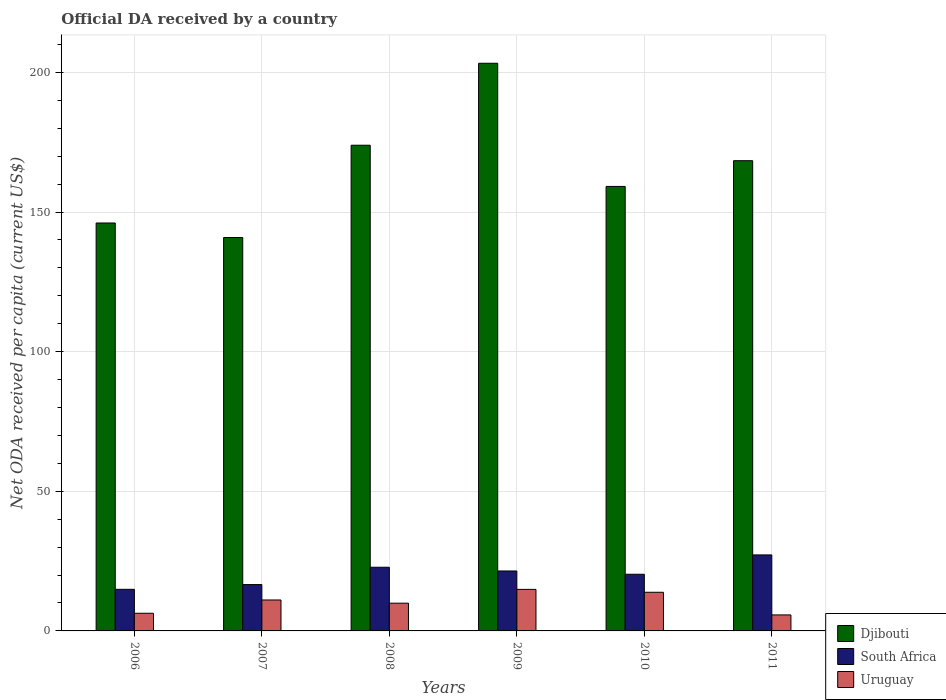How many different coloured bars are there?
Make the answer very short. 3. Are the number of bars per tick equal to the number of legend labels?
Ensure brevity in your answer.  Yes. How many bars are there on the 1st tick from the left?
Make the answer very short. 3. What is the label of the 5th group of bars from the left?
Your answer should be compact. 2010. What is the ODA received in in Djibouti in 2010?
Ensure brevity in your answer.  159.17. Across all years, what is the maximum ODA received in in Uruguay?
Give a very brief answer. 14.88. Across all years, what is the minimum ODA received in in Uruguay?
Make the answer very short. 5.73. In which year was the ODA received in in Djibouti maximum?
Offer a terse response. 2009. In which year was the ODA received in in South Africa minimum?
Provide a succinct answer. 2006. What is the total ODA received in in Djibouti in the graph?
Provide a succinct answer. 991.74. What is the difference between the ODA received in in Uruguay in 2008 and that in 2009?
Make the answer very short. -4.94. What is the difference between the ODA received in in Djibouti in 2007 and the ODA received in in Uruguay in 2009?
Provide a short and direct response. 126.01. What is the average ODA received in in South Africa per year?
Provide a succinct answer. 20.55. In the year 2007, what is the difference between the ODA received in in Djibouti and ODA received in in South Africa?
Ensure brevity in your answer.  124.29. In how many years, is the ODA received in in South Africa greater than 180 US$?
Make the answer very short. 0. What is the ratio of the ODA received in in South Africa in 2006 to that in 2011?
Provide a short and direct response. 0.55. Is the ODA received in in Djibouti in 2006 less than that in 2009?
Keep it short and to the point. Yes. Is the difference between the ODA received in in Djibouti in 2009 and 2010 greater than the difference between the ODA received in in South Africa in 2009 and 2010?
Give a very brief answer. Yes. What is the difference between the highest and the second highest ODA received in in South Africa?
Your answer should be compact. 4.41. What is the difference between the highest and the lowest ODA received in in Uruguay?
Your answer should be very brief. 9.15. Is the sum of the ODA received in in South Africa in 2008 and 2011 greater than the maximum ODA received in in Uruguay across all years?
Ensure brevity in your answer.  Yes. What does the 3rd bar from the left in 2006 represents?
Make the answer very short. Uruguay. What does the 3rd bar from the right in 2011 represents?
Offer a terse response. Djibouti. How many bars are there?
Your answer should be very brief. 18. Are all the bars in the graph horizontal?
Your response must be concise. No. What is the difference between two consecutive major ticks on the Y-axis?
Offer a terse response. 50. Are the values on the major ticks of Y-axis written in scientific E-notation?
Provide a short and direct response. No. Does the graph contain any zero values?
Make the answer very short. No. Where does the legend appear in the graph?
Offer a terse response. Bottom right. How many legend labels are there?
Your answer should be compact. 3. What is the title of the graph?
Give a very brief answer. Official DA received by a country. Does "Eritrea" appear as one of the legend labels in the graph?
Offer a very short reply. No. What is the label or title of the Y-axis?
Provide a short and direct response. Net ODA received per capita (current US$). What is the Net ODA received per capita (current US$) of Djibouti in 2006?
Offer a terse response. 146.08. What is the Net ODA received per capita (current US$) in South Africa in 2006?
Ensure brevity in your answer.  14.9. What is the Net ODA received per capita (current US$) of Uruguay in 2006?
Make the answer very short. 6.33. What is the Net ODA received per capita (current US$) in Djibouti in 2007?
Ensure brevity in your answer.  140.88. What is the Net ODA received per capita (current US$) in South Africa in 2007?
Provide a short and direct response. 16.6. What is the Net ODA received per capita (current US$) in Uruguay in 2007?
Give a very brief answer. 11.08. What is the Net ODA received per capita (current US$) of Djibouti in 2008?
Provide a short and direct response. 173.93. What is the Net ODA received per capita (current US$) of South Africa in 2008?
Offer a terse response. 22.8. What is the Net ODA received per capita (current US$) of Uruguay in 2008?
Provide a succinct answer. 9.93. What is the Net ODA received per capita (current US$) of Djibouti in 2009?
Give a very brief answer. 203.28. What is the Net ODA received per capita (current US$) in South Africa in 2009?
Offer a terse response. 21.47. What is the Net ODA received per capita (current US$) of Uruguay in 2009?
Ensure brevity in your answer.  14.88. What is the Net ODA received per capita (current US$) of Djibouti in 2010?
Your answer should be compact. 159.17. What is the Net ODA received per capita (current US$) of South Africa in 2010?
Offer a terse response. 20.29. What is the Net ODA received per capita (current US$) of Uruguay in 2010?
Ensure brevity in your answer.  13.84. What is the Net ODA received per capita (current US$) in Djibouti in 2011?
Provide a succinct answer. 168.39. What is the Net ODA received per capita (current US$) in South Africa in 2011?
Give a very brief answer. 27.22. What is the Net ODA received per capita (current US$) in Uruguay in 2011?
Provide a succinct answer. 5.73. Across all years, what is the maximum Net ODA received per capita (current US$) of Djibouti?
Offer a very short reply. 203.28. Across all years, what is the maximum Net ODA received per capita (current US$) in South Africa?
Give a very brief answer. 27.22. Across all years, what is the maximum Net ODA received per capita (current US$) in Uruguay?
Your answer should be very brief. 14.88. Across all years, what is the minimum Net ODA received per capita (current US$) of Djibouti?
Your response must be concise. 140.88. Across all years, what is the minimum Net ODA received per capita (current US$) in South Africa?
Make the answer very short. 14.9. Across all years, what is the minimum Net ODA received per capita (current US$) in Uruguay?
Keep it short and to the point. 5.73. What is the total Net ODA received per capita (current US$) in Djibouti in the graph?
Provide a succinct answer. 991.74. What is the total Net ODA received per capita (current US$) of South Africa in the graph?
Provide a succinct answer. 123.27. What is the total Net ODA received per capita (current US$) in Uruguay in the graph?
Offer a terse response. 61.79. What is the difference between the Net ODA received per capita (current US$) of Djibouti in 2006 and that in 2007?
Ensure brevity in your answer.  5.2. What is the difference between the Net ODA received per capita (current US$) of South Africa in 2006 and that in 2007?
Offer a terse response. -1.7. What is the difference between the Net ODA received per capita (current US$) of Uruguay in 2006 and that in 2007?
Offer a very short reply. -4.76. What is the difference between the Net ODA received per capita (current US$) in Djibouti in 2006 and that in 2008?
Your answer should be compact. -27.85. What is the difference between the Net ODA received per capita (current US$) in South Africa in 2006 and that in 2008?
Your response must be concise. -7.9. What is the difference between the Net ODA received per capita (current US$) of Uruguay in 2006 and that in 2008?
Provide a short and direct response. -3.61. What is the difference between the Net ODA received per capita (current US$) of Djibouti in 2006 and that in 2009?
Keep it short and to the point. -57.2. What is the difference between the Net ODA received per capita (current US$) in South Africa in 2006 and that in 2009?
Your answer should be compact. -6.57. What is the difference between the Net ODA received per capita (current US$) in Uruguay in 2006 and that in 2009?
Make the answer very short. -8.55. What is the difference between the Net ODA received per capita (current US$) of Djibouti in 2006 and that in 2010?
Your response must be concise. -13.09. What is the difference between the Net ODA received per capita (current US$) in South Africa in 2006 and that in 2010?
Offer a very short reply. -5.39. What is the difference between the Net ODA received per capita (current US$) of Uruguay in 2006 and that in 2010?
Your answer should be compact. -7.52. What is the difference between the Net ODA received per capita (current US$) in Djibouti in 2006 and that in 2011?
Provide a succinct answer. -22.31. What is the difference between the Net ODA received per capita (current US$) of South Africa in 2006 and that in 2011?
Provide a succinct answer. -12.32. What is the difference between the Net ODA received per capita (current US$) of Uruguay in 2006 and that in 2011?
Provide a short and direct response. 0.6. What is the difference between the Net ODA received per capita (current US$) in Djibouti in 2007 and that in 2008?
Ensure brevity in your answer.  -33.05. What is the difference between the Net ODA received per capita (current US$) in South Africa in 2007 and that in 2008?
Provide a succinct answer. -6.21. What is the difference between the Net ODA received per capita (current US$) in Uruguay in 2007 and that in 2008?
Offer a terse response. 1.15. What is the difference between the Net ODA received per capita (current US$) of Djibouti in 2007 and that in 2009?
Make the answer very short. -62.4. What is the difference between the Net ODA received per capita (current US$) in South Africa in 2007 and that in 2009?
Provide a short and direct response. -4.87. What is the difference between the Net ODA received per capita (current US$) of Uruguay in 2007 and that in 2009?
Your response must be concise. -3.8. What is the difference between the Net ODA received per capita (current US$) of Djibouti in 2007 and that in 2010?
Your response must be concise. -18.29. What is the difference between the Net ODA received per capita (current US$) in South Africa in 2007 and that in 2010?
Your answer should be very brief. -3.69. What is the difference between the Net ODA received per capita (current US$) in Uruguay in 2007 and that in 2010?
Offer a very short reply. -2.76. What is the difference between the Net ODA received per capita (current US$) of Djibouti in 2007 and that in 2011?
Your answer should be compact. -27.5. What is the difference between the Net ODA received per capita (current US$) of South Africa in 2007 and that in 2011?
Your response must be concise. -10.62. What is the difference between the Net ODA received per capita (current US$) of Uruguay in 2007 and that in 2011?
Ensure brevity in your answer.  5.35. What is the difference between the Net ODA received per capita (current US$) in Djibouti in 2008 and that in 2009?
Offer a terse response. -29.35. What is the difference between the Net ODA received per capita (current US$) in South Africa in 2008 and that in 2009?
Ensure brevity in your answer.  1.34. What is the difference between the Net ODA received per capita (current US$) in Uruguay in 2008 and that in 2009?
Offer a very short reply. -4.94. What is the difference between the Net ODA received per capita (current US$) of Djibouti in 2008 and that in 2010?
Provide a succinct answer. 14.76. What is the difference between the Net ODA received per capita (current US$) in South Africa in 2008 and that in 2010?
Make the answer very short. 2.51. What is the difference between the Net ODA received per capita (current US$) of Uruguay in 2008 and that in 2010?
Give a very brief answer. -3.91. What is the difference between the Net ODA received per capita (current US$) of Djibouti in 2008 and that in 2011?
Provide a short and direct response. 5.54. What is the difference between the Net ODA received per capita (current US$) of South Africa in 2008 and that in 2011?
Your answer should be compact. -4.41. What is the difference between the Net ODA received per capita (current US$) in Uruguay in 2008 and that in 2011?
Provide a short and direct response. 4.2. What is the difference between the Net ODA received per capita (current US$) of Djibouti in 2009 and that in 2010?
Your answer should be very brief. 44.11. What is the difference between the Net ODA received per capita (current US$) in South Africa in 2009 and that in 2010?
Offer a terse response. 1.18. What is the difference between the Net ODA received per capita (current US$) of Uruguay in 2009 and that in 2010?
Offer a very short reply. 1.04. What is the difference between the Net ODA received per capita (current US$) of Djibouti in 2009 and that in 2011?
Provide a succinct answer. 34.89. What is the difference between the Net ODA received per capita (current US$) in South Africa in 2009 and that in 2011?
Offer a terse response. -5.75. What is the difference between the Net ODA received per capita (current US$) in Uruguay in 2009 and that in 2011?
Provide a short and direct response. 9.15. What is the difference between the Net ODA received per capita (current US$) of Djibouti in 2010 and that in 2011?
Keep it short and to the point. -9.22. What is the difference between the Net ODA received per capita (current US$) in South Africa in 2010 and that in 2011?
Your answer should be very brief. -6.93. What is the difference between the Net ODA received per capita (current US$) in Uruguay in 2010 and that in 2011?
Make the answer very short. 8.11. What is the difference between the Net ODA received per capita (current US$) in Djibouti in 2006 and the Net ODA received per capita (current US$) in South Africa in 2007?
Give a very brief answer. 129.49. What is the difference between the Net ODA received per capita (current US$) in Djibouti in 2006 and the Net ODA received per capita (current US$) in Uruguay in 2007?
Offer a very short reply. 135. What is the difference between the Net ODA received per capita (current US$) in South Africa in 2006 and the Net ODA received per capita (current US$) in Uruguay in 2007?
Give a very brief answer. 3.82. What is the difference between the Net ODA received per capita (current US$) in Djibouti in 2006 and the Net ODA received per capita (current US$) in South Africa in 2008?
Your response must be concise. 123.28. What is the difference between the Net ODA received per capita (current US$) in Djibouti in 2006 and the Net ODA received per capita (current US$) in Uruguay in 2008?
Your answer should be very brief. 136.15. What is the difference between the Net ODA received per capita (current US$) in South Africa in 2006 and the Net ODA received per capita (current US$) in Uruguay in 2008?
Make the answer very short. 4.96. What is the difference between the Net ODA received per capita (current US$) in Djibouti in 2006 and the Net ODA received per capita (current US$) in South Africa in 2009?
Provide a short and direct response. 124.61. What is the difference between the Net ODA received per capita (current US$) of Djibouti in 2006 and the Net ODA received per capita (current US$) of Uruguay in 2009?
Keep it short and to the point. 131.2. What is the difference between the Net ODA received per capita (current US$) of South Africa in 2006 and the Net ODA received per capita (current US$) of Uruguay in 2009?
Offer a very short reply. 0.02. What is the difference between the Net ODA received per capita (current US$) of Djibouti in 2006 and the Net ODA received per capita (current US$) of South Africa in 2010?
Keep it short and to the point. 125.79. What is the difference between the Net ODA received per capita (current US$) of Djibouti in 2006 and the Net ODA received per capita (current US$) of Uruguay in 2010?
Make the answer very short. 132.24. What is the difference between the Net ODA received per capita (current US$) of South Africa in 2006 and the Net ODA received per capita (current US$) of Uruguay in 2010?
Offer a very short reply. 1.06. What is the difference between the Net ODA received per capita (current US$) of Djibouti in 2006 and the Net ODA received per capita (current US$) of South Africa in 2011?
Provide a succinct answer. 118.86. What is the difference between the Net ODA received per capita (current US$) in Djibouti in 2006 and the Net ODA received per capita (current US$) in Uruguay in 2011?
Provide a succinct answer. 140.35. What is the difference between the Net ODA received per capita (current US$) in South Africa in 2006 and the Net ODA received per capita (current US$) in Uruguay in 2011?
Offer a very short reply. 9.17. What is the difference between the Net ODA received per capita (current US$) in Djibouti in 2007 and the Net ODA received per capita (current US$) in South Africa in 2008?
Ensure brevity in your answer.  118.08. What is the difference between the Net ODA received per capita (current US$) in Djibouti in 2007 and the Net ODA received per capita (current US$) in Uruguay in 2008?
Ensure brevity in your answer.  130.95. What is the difference between the Net ODA received per capita (current US$) in South Africa in 2007 and the Net ODA received per capita (current US$) in Uruguay in 2008?
Provide a succinct answer. 6.66. What is the difference between the Net ODA received per capita (current US$) in Djibouti in 2007 and the Net ODA received per capita (current US$) in South Africa in 2009?
Provide a short and direct response. 119.42. What is the difference between the Net ODA received per capita (current US$) of Djibouti in 2007 and the Net ODA received per capita (current US$) of Uruguay in 2009?
Offer a terse response. 126.01. What is the difference between the Net ODA received per capita (current US$) in South Africa in 2007 and the Net ODA received per capita (current US$) in Uruguay in 2009?
Offer a very short reply. 1.72. What is the difference between the Net ODA received per capita (current US$) of Djibouti in 2007 and the Net ODA received per capita (current US$) of South Africa in 2010?
Your answer should be compact. 120.59. What is the difference between the Net ODA received per capita (current US$) of Djibouti in 2007 and the Net ODA received per capita (current US$) of Uruguay in 2010?
Your answer should be very brief. 127.04. What is the difference between the Net ODA received per capita (current US$) in South Africa in 2007 and the Net ODA received per capita (current US$) in Uruguay in 2010?
Offer a very short reply. 2.75. What is the difference between the Net ODA received per capita (current US$) in Djibouti in 2007 and the Net ODA received per capita (current US$) in South Africa in 2011?
Offer a terse response. 113.67. What is the difference between the Net ODA received per capita (current US$) of Djibouti in 2007 and the Net ODA received per capita (current US$) of Uruguay in 2011?
Ensure brevity in your answer.  135.15. What is the difference between the Net ODA received per capita (current US$) of South Africa in 2007 and the Net ODA received per capita (current US$) of Uruguay in 2011?
Your answer should be compact. 10.87. What is the difference between the Net ODA received per capita (current US$) in Djibouti in 2008 and the Net ODA received per capita (current US$) in South Africa in 2009?
Offer a terse response. 152.46. What is the difference between the Net ODA received per capita (current US$) in Djibouti in 2008 and the Net ODA received per capita (current US$) in Uruguay in 2009?
Make the answer very short. 159.05. What is the difference between the Net ODA received per capita (current US$) in South Africa in 2008 and the Net ODA received per capita (current US$) in Uruguay in 2009?
Provide a succinct answer. 7.92. What is the difference between the Net ODA received per capita (current US$) in Djibouti in 2008 and the Net ODA received per capita (current US$) in South Africa in 2010?
Provide a short and direct response. 153.64. What is the difference between the Net ODA received per capita (current US$) in Djibouti in 2008 and the Net ODA received per capita (current US$) in Uruguay in 2010?
Your answer should be very brief. 160.09. What is the difference between the Net ODA received per capita (current US$) of South Africa in 2008 and the Net ODA received per capita (current US$) of Uruguay in 2010?
Your answer should be compact. 8.96. What is the difference between the Net ODA received per capita (current US$) in Djibouti in 2008 and the Net ODA received per capita (current US$) in South Africa in 2011?
Keep it short and to the point. 146.71. What is the difference between the Net ODA received per capita (current US$) in Djibouti in 2008 and the Net ODA received per capita (current US$) in Uruguay in 2011?
Give a very brief answer. 168.2. What is the difference between the Net ODA received per capita (current US$) in South Africa in 2008 and the Net ODA received per capita (current US$) in Uruguay in 2011?
Provide a succinct answer. 17.07. What is the difference between the Net ODA received per capita (current US$) in Djibouti in 2009 and the Net ODA received per capita (current US$) in South Africa in 2010?
Ensure brevity in your answer.  182.99. What is the difference between the Net ODA received per capita (current US$) in Djibouti in 2009 and the Net ODA received per capita (current US$) in Uruguay in 2010?
Your answer should be very brief. 189.44. What is the difference between the Net ODA received per capita (current US$) in South Africa in 2009 and the Net ODA received per capita (current US$) in Uruguay in 2010?
Your answer should be compact. 7.62. What is the difference between the Net ODA received per capita (current US$) of Djibouti in 2009 and the Net ODA received per capita (current US$) of South Africa in 2011?
Your answer should be compact. 176.06. What is the difference between the Net ODA received per capita (current US$) in Djibouti in 2009 and the Net ODA received per capita (current US$) in Uruguay in 2011?
Provide a succinct answer. 197.55. What is the difference between the Net ODA received per capita (current US$) in South Africa in 2009 and the Net ODA received per capita (current US$) in Uruguay in 2011?
Provide a short and direct response. 15.74. What is the difference between the Net ODA received per capita (current US$) of Djibouti in 2010 and the Net ODA received per capita (current US$) of South Africa in 2011?
Your response must be concise. 131.95. What is the difference between the Net ODA received per capita (current US$) of Djibouti in 2010 and the Net ODA received per capita (current US$) of Uruguay in 2011?
Ensure brevity in your answer.  153.44. What is the difference between the Net ODA received per capita (current US$) in South Africa in 2010 and the Net ODA received per capita (current US$) in Uruguay in 2011?
Provide a succinct answer. 14.56. What is the average Net ODA received per capita (current US$) of Djibouti per year?
Keep it short and to the point. 165.29. What is the average Net ODA received per capita (current US$) in South Africa per year?
Keep it short and to the point. 20.55. What is the average Net ODA received per capita (current US$) in Uruguay per year?
Your answer should be very brief. 10.3. In the year 2006, what is the difference between the Net ODA received per capita (current US$) in Djibouti and Net ODA received per capita (current US$) in South Africa?
Offer a terse response. 131.18. In the year 2006, what is the difference between the Net ODA received per capita (current US$) in Djibouti and Net ODA received per capita (current US$) in Uruguay?
Offer a terse response. 139.76. In the year 2006, what is the difference between the Net ODA received per capita (current US$) in South Africa and Net ODA received per capita (current US$) in Uruguay?
Your answer should be very brief. 8.57. In the year 2007, what is the difference between the Net ODA received per capita (current US$) in Djibouti and Net ODA received per capita (current US$) in South Africa?
Your answer should be very brief. 124.29. In the year 2007, what is the difference between the Net ODA received per capita (current US$) in Djibouti and Net ODA received per capita (current US$) in Uruguay?
Your answer should be compact. 129.8. In the year 2007, what is the difference between the Net ODA received per capita (current US$) of South Africa and Net ODA received per capita (current US$) of Uruguay?
Provide a succinct answer. 5.51. In the year 2008, what is the difference between the Net ODA received per capita (current US$) in Djibouti and Net ODA received per capita (current US$) in South Africa?
Offer a terse response. 151.13. In the year 2008, what is the difference between the Net ODA received per capita (current US$) of Djibouti and Net ODA received per capita (current US$) of Uruguay?
Offer a terse response. 163.99. In the year 2008, what is the difference between the Net ODA received per capita (current US$) in South Africa and Net ODA received per capita (current US$) in Uruguay?
Offer a very short reply. 12.87. In the year 2009, what is the difference between the Net ODA received per capita (current US$) in Djibouti and Net ODA received per capita (current US$) in South Africa?
Your answer should be very brief. 181.81. In the year 2009, what is the difference between the Net ODA received per capita (current US$) in Djibouti and Net ODA received per capita (current US$) in Uruguay?
Keep it short and to the point. 188.4. In the year 2009, what is the difference between the Net ODA received per capita (current US$) in South Africa and Net ODA received per capita (current US$) in Uruguay?
Your response must be concise. 6.59. In the year 2010, what is the difference between the Net ODA received per capita (current US$) in Djibouti and Net ODA received per capita (current US$) in South Africa?
Provide a short and direct response. 138.88. In the year 2010, what is the difference between the Net ODA received per capita (current US$) in Djibouti and Net ODA received per capita (current US$) in Uruguay?
Give a very brief answer. 145.33. In the year 2010, what is the difference between the Net ODA received per capita (current US$) of South Africa and Net ODA received per capita (current US$) of Uruguay?
Ensure brevity in your answer.  6.45. In the year 2011, what is the difference between the Net ODA received per capita (current US$) in Djibouti and Net ODA received per capita (current US$) in South Africa?
Provide a short and direct response. 141.17. In the year 2011, what is the difference between the Net ODA received per capita (current US$) in Djibouti and Net ODA received per capita (current US$) in Uruguay?
Your answer should be compact. 162.66. In the year 2011, what is the difference between the Net ODA received per capita (current US$) of South Africa and Net ODA received per capita (current US$) of Uruguay?
Keep it short and to the point. 21.49. What is the ratio of the Net ODA received per capita (current US$) of Djibouti in 2006 to that in 2007?
Offer a very short reply. 1.04. What is the ratio of the Net ODA received per capita (current US$) of South Africa in 2006 to that in 2007?
Your answer should be very brief. 0.9. What is the ratio of the Net ODA received per capita (current US$) in Uruguay in 2006 to that in 2007?
Keep it short and to the point. 0.57. What is the ratio of the Net ODA received per capita (current US$) of Djibouti in 2006 to that in 2008?
Give a very brief answer. 0.84. What is the ratio of the Net ODA received per capita (current US$) of South Africa in 2006 to that in 2008?
Your answer should be very brief. 0.65. What is the ratio of the Net ODA received per capita (current US$) of Uruguay in 2006 to that in 2008?
Your answer should be very brief. 0.64. What is the ratio of the Net ODA received per capita (current US$) of Djibouti in 2006 to that in 2009?
Offer a terse response. 0.72. What is the ratio of the Net ODA received per capita (current US$) in South Africa in 2006 to that in 2009?
Offer a very short reply. 0.69. What is the ratio of the Net ODA received per capita (current US$) in Uruguay in 2006 to that in 2009?
Make the answer very short. 0.43. What is the ratio of the Net ODA received per capita (current US$) of Djibouti in 2006 to that in 2010?
Provide a succinct answer. 0.92. What is the ratio of the Net ODA received per capita (current US$) of South Africa in 2006 to that in 2010?
Your response must be concise. 0.73. What is the ratio of the Net ODA received per capita (current US$) of Uruguay in 2006 to that in 2010?
Your response must be concise. 0.46. What is the ratio of the Net ODA received per capita (current US$) of Djibouti in 2006 to that in 2011?
Offer a terse response. 0.87. What is the ratio of the Net ODA received per capita (current US$) in South Africa in 2006 to that in 2011?
Provide a short and direct response. 0.55. What is the ratio of the Net ODA received per capita (current US$) of Uruguay in 2006 to that in 2011?
Your answer should be compact. 1.1. What is the ratio of the Net ODA received per capita (current US$) of Djibouti in 2007 to that in 2008?
Provide a succinct answer. 0.81. What is the ratio of the Net ODA received per capita (current US$) of South Africa in 2007 to that in 2008?
Offer a terse response. 0.73. What is the ratio of the Net ODA received per capita (current US$) in Uruguay in 2007 to that in 2008?
Ensure brevity in your answer.  1.12. What is the ratio of the Net ODA received per capita (current US$) of Djibouti in 2007 to that in 2009?
Ensure brevity in your answer.  0.69. What is the ratio of the Net ODA received per capita (current US$) of South Africa in 2007 to that in 2009?
Offer a terse response. 0.77. What is the ratio of the Net ODA received per capita (current US$) in Uruguay in 2007 to that in 2009?
Make the answer very short. 0.74. What is the ratio of the Net ODA received per capita (current US$) in Djibouti in 2007 to that in 2010?
Offer a very short reply. 0.89. What is the ratio of the Net ODA received per capita (current US$) of South Africa in 2007 to that in 2010?
Provide a succinct answer. 0.82. What is the ratio of the Net ODA received per capita (current US$) in Uruguay in 2007 to that in 2010?
Your answer should be very brief. 0.8. What is the ratio of the Net ODA received per capita (current US$) of Djibouti in 2007 to that in 2011?
Your answer should be compact. 0.84. What is the ratio of the Net ODA received per capita (current US$) of South Africa in 2007 to that in 2011?
Give a very brief answer. 0.61. What is the ratio of the Net ODA received per capita (current US$) of Uruguay in 2007 to that in 2011?
Your answer should be compact. 1.93. What is the ratio of the Net ODA received per capita (current US$) of Djibouti in 2008 to that in 2009?
Give a very brief answer. 0.86. What is the ratio of the Net ODA received per capita (current US$) of South Africa in 2008 to that in 2009?
Ensure brevity in your answer.  1.06. What is the ratio of the Net ODA received per capita (current US$) of Uruguay in 2008 to that in 2009?
Ensure brevity in your answer.  0.67. What is the ratio of the Net ODA received per capita (current US$) of Djibouti in 2008 to that in 2010?
Offer a terse response. 1.09. What is the ratio of the Net ODA received per capita (current US$) in South Africa in 2008 to that in 2010?
Give a very brief answer. 1.12. What is the ratio of the Net ODA received per capita (current US$) in Uruguay in 2008 to that in 2010?
Offer a terse response. 0.72. What is the ratio of the Net ODA received per capita (current US$) in Djibouti in 2008 to that in 2011?
Your answer should be very brief. 1.03. What is the ratio of the Net ODA received per capita (current US$) of South Africa in 2008 to that in 2011?
Give a very brief answer. 0.84. What is the ratio of the Net ODA received per capita (current US$) of Uruguay in 2008 to that in 2011?
Make the answer very short. 1.73. What is the ratio of the Net ODA received per capita (current US$) in Djibouti in 2009 to that in 2010?
Your answer should be compact. 1.28. What is the ratio of the Net ODA received per capita (current US$) of South Africa in 2009 to that in 2010?
Give a very brief answer. 1.06. What is the ratio of the Net ODA received per capita (current US$) in Uruguay in 2009 to that in 2010?
Give a very brief answer. 1.07. What is the ratio of the Net ODA received per capita (current US$) in Djibouti in 2009 to that in 2011?
Offer a terse response. 1.21. What is the ratio of the Net ODA received per capita (current US$) of South Africa in 2009 to that in 2011?
Make the answer very short. 0.79. What is the ratio of the Net ODA received per capita (current US$) of Uruguay in 2009 to that in 2011?
Your answer should be very brief. 2.6. What is the ratio of the Net ODA received per capita (current US$) in Djibouti in 2010 to that in 2011?
Keep it short and to the point. 0.95. What is the ratio of the Net ODA received per capita (current US$) of South Africa in 2010 to that in 2011?
Ensure brevity in your answer.  0.75. What is the ratio of the Net ODA received per capita (current US$) in Uruguay in 2010 to that in 2011?
Your answer should be very brief. 2.42. What is the difference between the highest and the second highest Net ODA received per capita (current US$) of Djibouti?
Make the answer very short. 29.35. What is the difference between the highest and the second highest Net ODA received per capita (current US$) in South Africa?
Your answer should be compact. 4.41. What is the difference between the highest and the second highest Net ODA received per capita (current US$) of Uruguay?
Offer a terse response. 1.04. What is the difference between the highest and the lowest Net ODA received per capita (current US$) in Djibouti?
Make the answer very short. 62.4. What is the difference between the highest and the lowest Net ODA received per capita (current US$) of South Africa?
Offer a terse response. 12.32. What is the difference between the highest and the lowest Net ODA received per capita (current US$) of Uruguay?
Give a very brief answer. 9.15. 